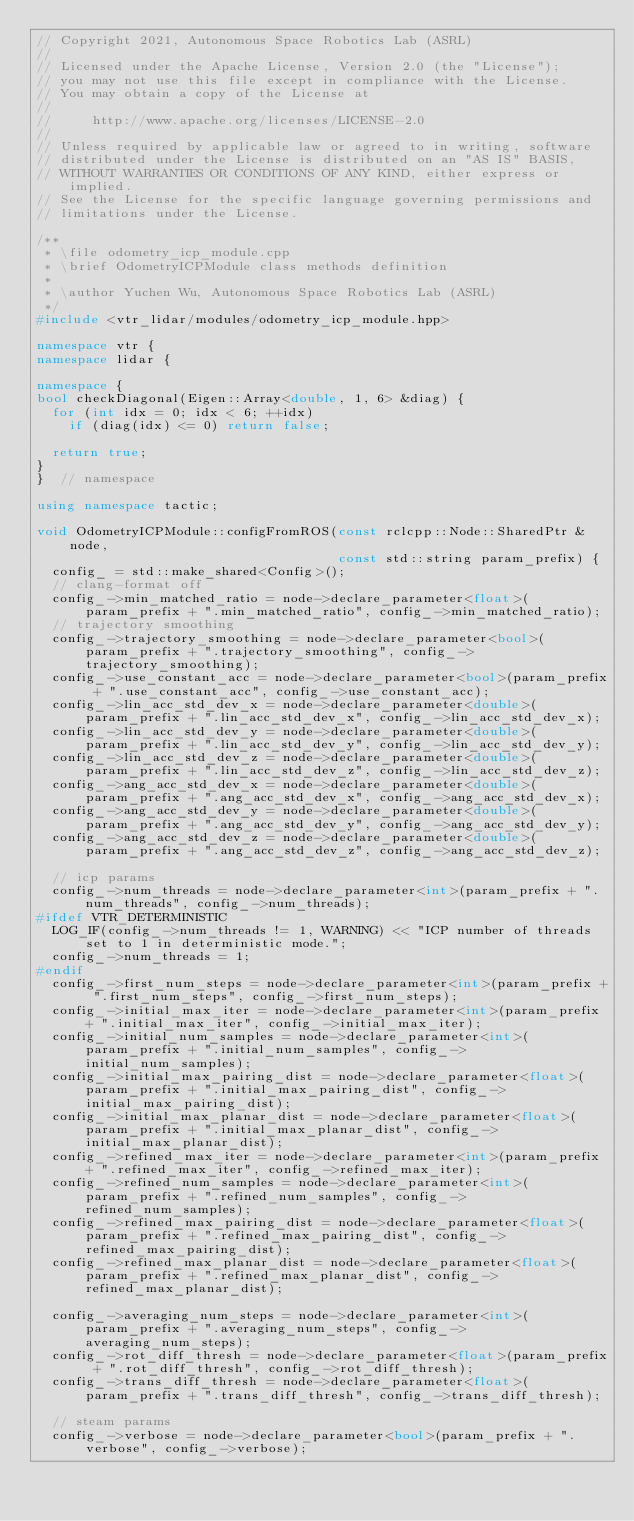<code> <loc_0><loc_0><loc_500><loc_500><_C++_>// Copyright 2021, Autonomous Space Robotics Lab (ASRL)
//
// Licensed under the Apache License, Version 2.0 (the "License");
// you may not use this file except in compliance with the License.
// You may obtain a copy of the License at
//
//     http://www.apache.org/licenses/LICENSE-2.0
//
// Unless required by applicable law or agreed to in writing, software
// distributed under the License is distributed on an "AS IS" BASIS,
// WITHOUT WARRANTIES OR CONDITIONS OF ANY KIND, either express or implied.
// See the License for the specific language governing permissions and
// limitations under the License.

/**
 * \file odometry_icp_module.cpp
 * \brief OdometryICPModule class methods definition
 *
 * \author Yuchen Wu, Autonomous Space Robotics Lab (ASRL)
 */
#include <vtr_lidar/modules/odometry_icp_module.hpp>

namespace vtr {
namespace lidar {

namespace {
bool checkDiagonal(Eigen::Array<double, 1, 6> &diag) {
  for (int idx = 0; idx < 6; ++idx)
    if (diag(idx) <= 0) return false;

  return true;
}
}  // namespace

using namespace tactic;

void OdometryICPModule::configFromROS(const rclcpp::Node::SharedPtr &node,
                                      const std::string param_prefix) {
  config_ = std::make_shared<Config>();
  // clang-format off
  config_->min_matched_ratio = node->declare_parameter<float>(param_prefix + ".min_matched_ratio", config_->min_matched_ratio);
  // trajectory smoothing
  config_->trajectory_smoothing = node->declare_parameter<bool>(param_prefix + ".trajectory_smoothing", config_->trajectory_smoothing);
  config_->use_constant_acc = node->declare_parameter<bool>(param_prefix + ".use_constant_acc", config_->use_constant_acc);
  config_->lin_acc_std_dev_x = node->declare_parameter<double>(param_prefix + ".lin_acc_std_dev_x", config_->lin_acc_std_dev_x);
  config_->lin_acc_std_dev_y = node->declare_parameter<double>(param_prefix + ".lin_acc_std_dev_y", config_->lin_acc_std_dev_y);
  config_->lin_acc_std_dev_z = node->declare_parameter<double>(param_prefix + ".lin_acc_std_dev_z", config_->lin_acc_std_dev_z);
  config_->ang_acc_std_dev_x = node->declare_parameter<double>(param_prefix + ".ang_acc_std_dev_x", config_->ang_acc_std_dev_x);
  config_->ang_acc_std_dev_y = node->declare_parameter<double>(param_prefix + ".ang_acc_std_dev_y", config_->ang_acc_std_dev_y);
  config_->ang_acc_std_dev_z = node->declare_parameter<double>(param_prefix + ".ang_acc_std_dev_z", config_->ang_acc_std_dev_z);

  // icp params
  config_->num_threads = node->declare_parameter<int>(param_prefix + ".num_threads", config_->num_threads);
#ifdef VTR_DETERMINISTIC
  LOG_IF(config_->num_threads != 1, WARNING) << "ICP number of threads set to 1 in deterministic mode.";
  config_->num_threads = 1;
#endif
  config_->first_num_steps = node->declare_parameter<int>(param_prefix + ".first_num_steps", config_->first_num_steps);
  config_->initial_max_iter = node->declare_parameter<int>(param_prefix + ".initial_max_iter", config_->initial_max_iter);
  config_->initial_num_samples = node->declare_parameter<int>(param_prefix + ".initial_num_samples", config_->initial_num_samples);
  config_->initial_max_pairing_dist = node->declare_parameter<float>(param_prefix + ".initial_max_pairing_dist", config_->initial_max_pairing_dist);
  config_->initial_max_planar_dist = node->declare_parameter<float>(param_prefix + ".initial_max_planar_dist", config_->initial_max_planar_dist);
  config_->refined_max_iter = node->declare_parameter<int>(param_prefix + ".refined_max_iter", config_->refined_max_iter);
  config_->refined_num_samples = node->declare_parameter<int>(param_prefix + ".refined_num_samples", config_->refined_num_samples);
  config_->refined_max_pairing_dist = node->declare_parameter<float>(param_prefix + ".refined_max_pairing_dist", config_->refined_max_pairing_dist);
  config_->refined_max_planar_dist = node->declare_parameter<float>(param_prefix + ".refined_max_planar_dist", config_->refined_max_planar_dist);

  config_->averaging_num_steps = node->declare_parameter<int>(param_prefix + ".averaging_num_steps", config_->averaging_num_steps);
  config_->rot_diff_thresh = node->declare_parameter<float>(param_prefix + ".rot_diff_thresh", config_->rot_diff_thresh);
  config_->trans_diff_thresh = node->declare_parameter<float>(param_prefix + ".trans_diff_thresh", config_->trans_diff_thresh);

  // steam params
  config_->verbose = node->declare_parameter<bool>(param_prefix + ".verbose", config_->verbose);</code> 